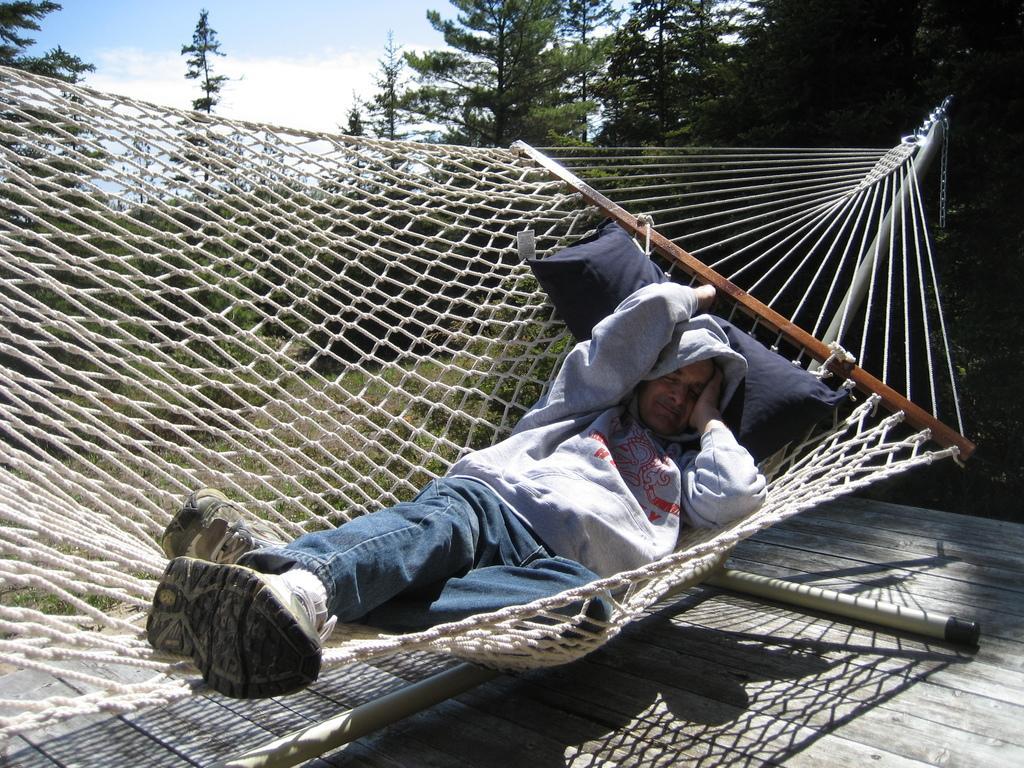Can you describe this image briefly? A person is sleeping on a hammock. There is a pillow. There are trees at the back. 